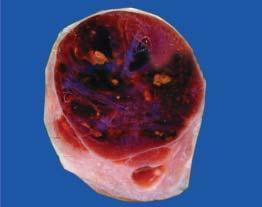does also show lobules of translucent gelatinous light brown parenchyma and areas of haemorrhage?
Answer the question using a single word or phrase. No 